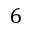<formula> <loc_0><loc_0><loc_500><loc_500>6</formula> 